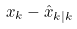<formula> <loc_0><loc_0><loc_500><loc_500>x _ { k } - \hat { x } _ { k | k }</formula> 